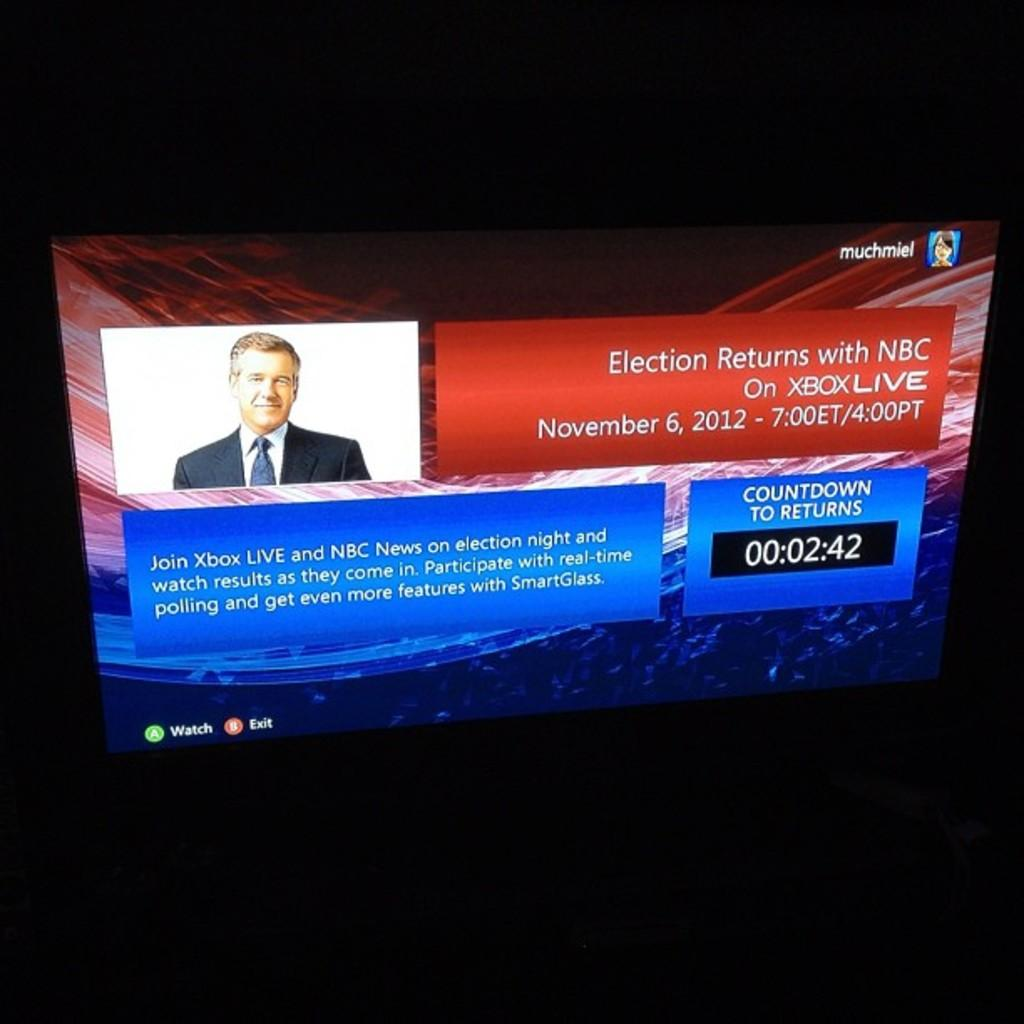What is the main object in the image? There is a poster in the image. What is depicted on the poster? The poster has a person's image. What else can be seen on the poster besides the image? There are texts and numbers on the poster. What is the color of the poster's background? The background of the poster is black. Where is the shelf located in the image? There is no shelf present in the image. What type of force is being applied to the poster in the image? There is no force being applied to the poster in the image; it is stationary. 